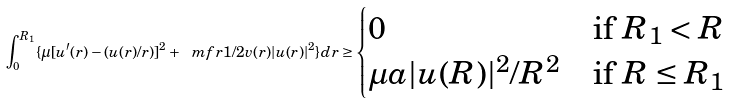Convert formula to latex. <formula><loc_0><loc_0><loc_500><loc_500>\int _ { 0 } ^ { R _ { 1 } } \{ \mu [ u ^ { \prime } ( r ) - ( u ( r ) / r ) ] ^ { 2 } + \ m f r 1 / 2 v ( r ) | u ( r ) | ^ { 2 } \} d r \geq \begin{cases} 0 & \text {if $R_{1}<R$} \\ \mu a | u ( R ) | ^ { 2 } / R ^ { 2 } & \text {if $R\leq R_{1}$} \end{cases}</formula> 